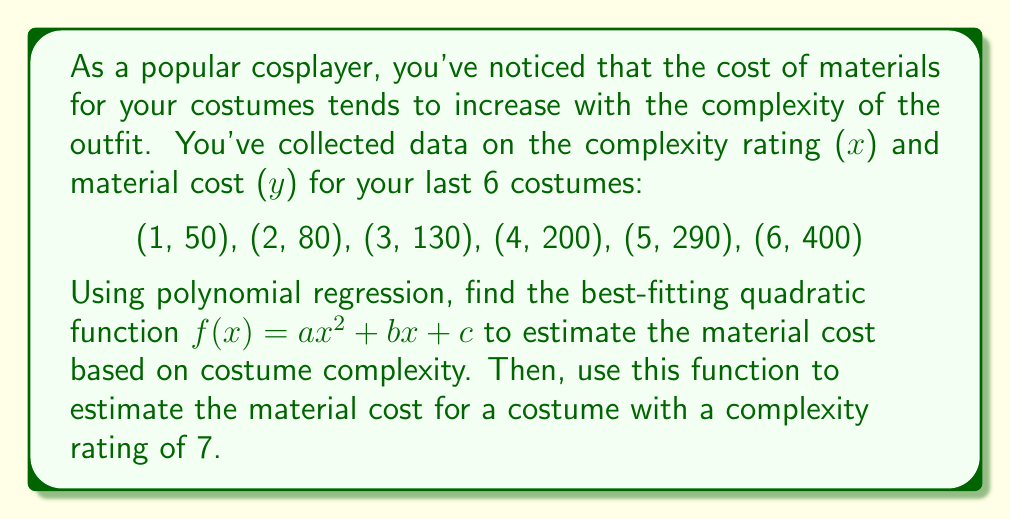Could you help me with this problem? To find the best-fitting quadratic function using polynomial regression, we need to solve a system of normal equations. For a quadratic function $f(x) = ax^2 + bx + c$, we have:

$$\begin{cases}
\sum x^4 a + \sum x^3 b + \sum x^2 c = \sum x^2 y \\
\sum x^3 a + \sum x^2 b + \sum x c = \sum xy \\
\sum x^2 a + \sum x b + n c = \sum y
\end{cases}$$

Let's calculate the required sums:

$\sum x = 21$
$\sum y = 1150$
$\sum x^2 = 91$
$\sum x^3 = 441$
$\sum x^4 = 2275$
$\sum xy = 4410$
$\sum x^2y = 18130$
$n = 6$

Substituting these values into the system of equations:

$$\begin{cases}
2275a + 441b + 91c = 18130 \\
441a + 91b + 21c = 4410 \\
91a + 21b + 6c = 1150
\end{cases}$$

Solving this system (using a calculator or computer algebra system), we get:

$a \approx 10$
$b \approx 10$
$c \approx 30$

Therefore, the best-fitting quadratic function is approximately:

$f(x) = 10x^2 + 10x + 30$

To estimate the material cost for a costume with a complexity rating of 7, we substitute x = 7 into our function:

$f(7) = 10(7^2) + 10(7) + 30 = 10(49) + 70 + 30 = 490 + 70 + 30 = 590$
Answer: The best-fitting quadratic function is $f(x) = 10x^2 + 10x + 30$, and the estimated material cost for a costume with a complexity rating of 7 is $590. 